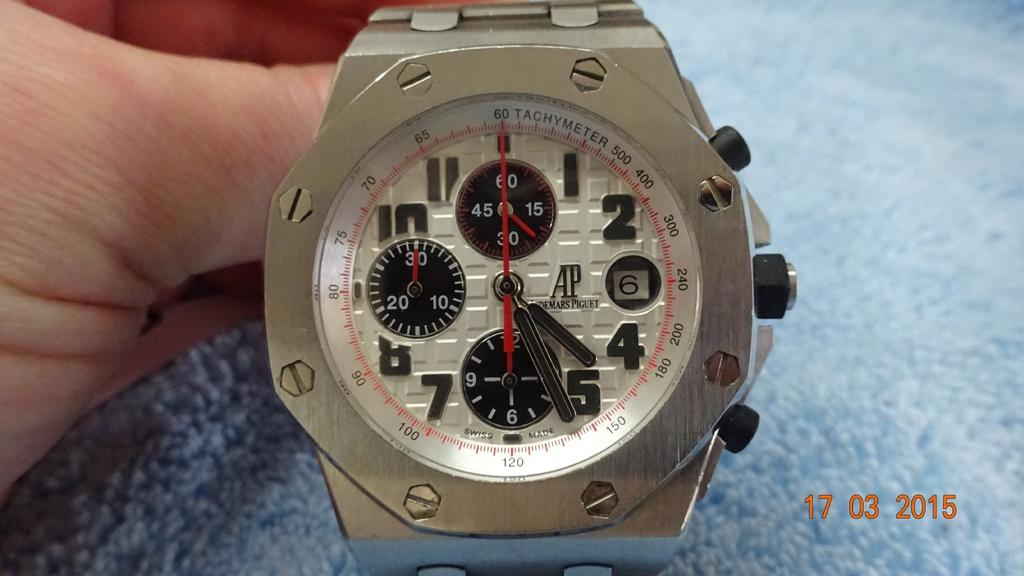<image>
Provide a brief description of the given image. A formidable looking watch has the initials AP on it. 